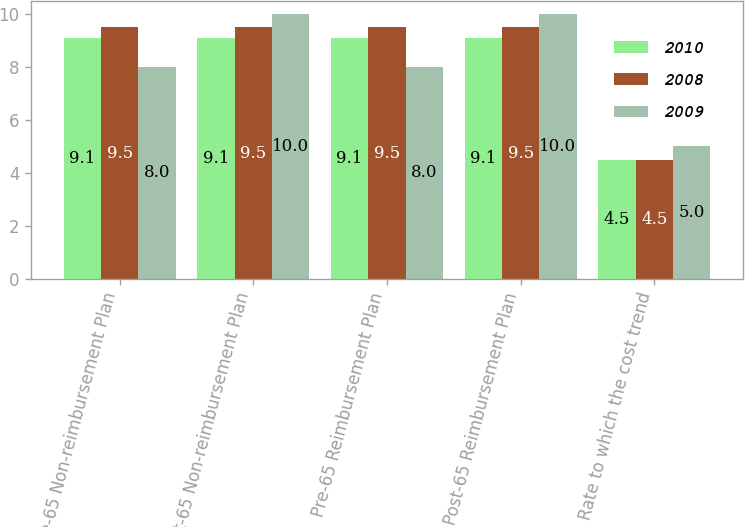Convert chart. <chart><loc_0><loc_0><loc_500><loc_500><stacked_bar_chart><ecel><fcel>Pre-65 Non-reimbursement Plan<fcel>Post-65 Non-reimbursement Plan<fcel>Pre-65 Reimbursement Plan<fcel>Post-65 Reimbursement Plan<fcel>Rate to which the cost trend<nl><fcel>2010<fcel>9.1<fcel>9.1<fcel>9.1<fcel>9.1<fcel>4.5<nl><fcel>2008<fcel>9.5<fcel>9.5<fcel>9.5<fcel>9.5<fcel>4.5<nl><fcel>2009<fcel>8<fcel>10<fcel>8<fcel>10<fcel>5<nl></chart> 